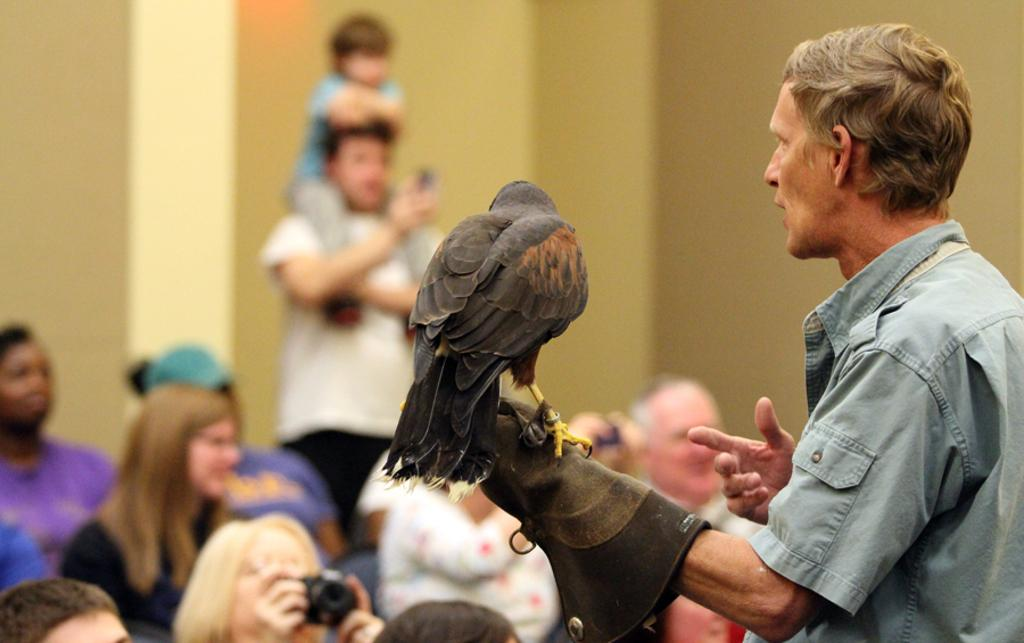Who or what is the main subject in the image? There is a person in the image. What is the person holding in their hand? A bird is on the person's left hand. Can you describe the people in front of the person? There are people sitting in front of the person. How would you describe the background of the image? The background of the image is blurry. What type of profit can be seen in the image? There is no mention of profit in the image; it features a person holding a bird with people sitting in front of them. Is there a coach visible in the image? There is no coach present in the image. 